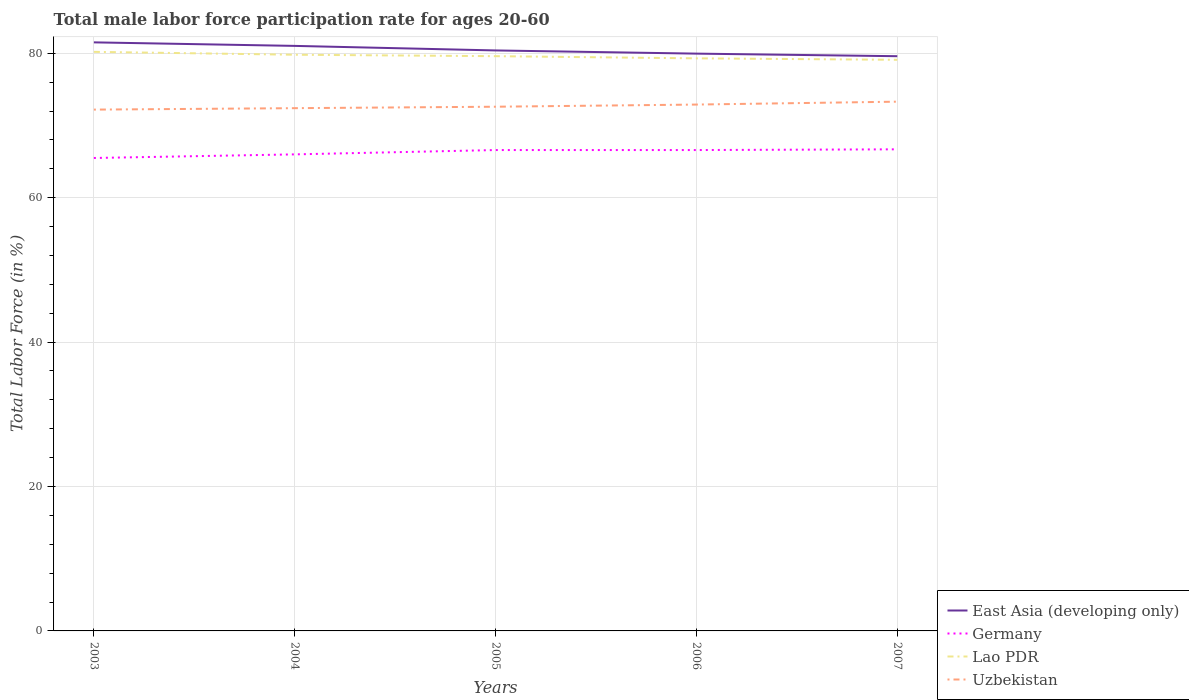Across all years, what is the maximum male labor force participation rate in East Asia (developing only)?
Give a very brief answer. 79.6. In which year was the male labor force participation rate in Lao PDR maximum?
Keep it short and to the point. 2007. What is the total male labor force participation rate in Germany in the graph?
Your answer should be compact. -0.6. What is the difference between the highest and the second highest male labor force participation rate in Lao PDR?
Offer a very short reply. 1.1. What is the difference between the highest and the lowest male labor force participation rate in Germany?
Your response must be concise. 3. What is the difference between two consecutive major ticks on the Y-axis?
Make the answer very short. 20. Are the values on the major ticks of Y-axis written in scientific E-notation?
Your answer should be compact. No. Does the graph contain grids?
Keep it short and to the point. Yes. How many legend labels are there?
Provide a succinct answer. 4. How are the legend labels stacked?
Offer a terse response. Vertical. What is the title of the graph?
Make the answer very short. Total male labor force participation rate for ages 20-60. Does "Isle of Man" appear as one of the legend labels in the graph?
Keep it short and to the point. No. What is the Total Labor Force (in %) of East Asia (developing only) in 2003?
Your answer should be very brief. 81.51. What is the Total Labor Force (in %) in Germany in 2003?
Your response must be concise. 65.5. What is the Total Labor Force (in %) of Lao PDR in 2003?
Provide a succinct answer. 80.2. What is the Total Labor Force (in %) in Uzbekistan in 2003?
Your response must be concise. 72.2. What is the Total Labor Force (in %) of East Asia (developing only) in 2004?
Your response must be concise. 81.02. What is the Total Labor Force (in %) of Germany in 2004?
Make the answer very short. 66. What is the Total Labor Force (in %) in Lao PDR in 2004?
Your response must be concise. 79.8. What is the Total Labor Force (in %) of Uzbekistan in 2004?
Offer a very short reply. 72.4. What is the Total Labor Force (in %) in East Asia (developing only) in 2005?
Ensure brevity in your answer.  80.39. What is the Total Labor Force (in %) in Germany in 2005?
Offer a terse response. 66.6. What is the Total Labor Force (in %) of Lao PDR in 2005?
Your response must be concise. 79.6. What is the Total Labor Force (in %) of Uzbekistan in 2005?
Make the answer very short. 72.6. What is the Total Labor Force (in %) in East Asia (developing only) in 2006?
Offer a terse response. 79.95. What is the Total Labor Force (in %) of Germany in 2006?
Your answer should be very brief. 66.6. What is the Total Labor Force (in %) of Lao PDR in 2006?
Provide a succinct answer. 79.3. What is the Total Labor Force (in %) in Uzbekistan in 2006?
Provide a short and direct response. 72.9. What is the Total Labor Force (in %) in East Asia (developing only) in 2007?
Your answer should be very brief. 79.6. What is the Total Labor Force (in %) of Germany in 2007?
Keep it short and to the point. 66.7. What is the Total Labor Force (in %) in Lao PDR in 2007?
Offer a terse response. 79.1. What is the Total Labor Force (in %) of Uzbekistan in 2007?
Offer a terse response. 73.3. Across all years, what is the maximum Total Labor Force (in %) of East Asia (developing only)?
Offer a terse response. 81.51. Across all years, what is the maximum Total Labor Force (in %) in Germany?
Offer a very short reply. 66.7. Across all years, what is the maximum Total Labor Force (in %) of Lao PDR?
Offer a terse response. 80.2. Across all years, what is the maximum Total Labor Force (in %) in Uzbekistan?
Your answer should be compact. 73.3. Across all years, what is the minimum Total Labor Force (in %) of East Asia (developing only)?
Offer a very short reply. 79.6. Across all years, what is the minimum Total Labor Force (in %) in Germany?
Your answer should be compact. 65.5. Across all years, what is the minimum Total Labor Force (in %) of Lao PDR?
Provide a succinct answer. 79.1. Across all years, what is the minimum Total Labor Force (in %) of Uzbekistan?
Keep it short and to the point. 72.2. What is the total Total Labor Force (in %) in East Asia (developing only) in the graph?
Ensure brevity in your answer.  402.48. What is the total Total Labor Force (in %) in Germany in the graph?
Give a very brief answer. 331.4. What is the total Total Labor Force (in %) of Lao PDR in the graph?
Provide a succinct answer. 398. What is the total Total Labor Force (in %) of Uzbekistan in the graph?
Offer a terse response. 363.4. What is the difference between the Total Labor Force (in %) of East Asia (developing only) in 2003 and that in 2004?
Your answer should be compact. 0.49. What is the difference between the Total Labor Force (in %) of Germany in 2003 and that in 2004?
Make the answer very short. -0.5. What is the difference between the Total Labor Force (in %) of Uzbekistan in 2003 and that in 2004?
Provide a short and direct response. -0.2. What is the difference between the Total Labor Force (in %) of East Asia (developing only) in 2003 and that in 2005?
Your response must be concise. 1.12. What is the difference between the Total Labor Force (in %) of Lao PDR in 2003 and that in 2005?
Give a very brief answer. 0.6. What is the difference between the Total Labor Force (in %) of Uzbekistan in 2003 and that in 2005?
Make the answer very short. -0.4. What is the difference between the Total Labor Force (in %) of East Asia (developing only) in 2003 and that in 2006?
Ensure brevity in your answer.  1.56. What is the difference between the Total Labor Force (in %) in Lao PDR in 2003 and that in 2006?
Your answer should be compact. 0.9. What is the difference between the Total Labor Force (in %) of East Asia (developing only) in 2003 and that in 2007?
Your answer should be very brief. 1.92. What is the difference between the Total Labor Force (in %) of Germany in 2003 and that in 2007?
Your response must be concise. -1.2. What is the difference between the Total Labor Force (in %) in East Asia (developing only) in 2004 and that in 2005?
Ensure brevity in your answer.  0.63. What is the difference between the Total Labor Force (in %) in East Asia (developing only) in 2004 and that in 2006?
Your response must be concise. 1.07. What is the difference between the Total Labor Force (in %) in East Asia (developing only) in 2004 and that in 2007?
Offer a very short reply. 1.43. What is the difference between the Total Labor Force (in %) of Uzbekistan in 2004 and that in 2007?
Make the answer very short. -0.9. What is the difference between the Total Labor Force (in %) in East Asia (developing only) in 2005 and that in 2006?
Your response must be concise. 0.44. What is the difference between the Total Labor Force (in %) in Germany in 2005 and that in 2006?
Ensure brevity in your answer.  0. What is the difference between the Total Labor Force (in %) in Lao PDR in 2005 and that in 2006?
Offer a very short reply. 0.3. What is the difference between the Total Labor Force (in %) in Uzbekistan in 2005 and that in 2006?
Provide a succinct answer. -0.3. What is the difference between the Total Labor Force (in %) of East Asia (developing only) in 2005 and that in 2007?
Your answer should be very brief. 0.8. What is the difference between the Total Labor Force (in %) in Uzbekistan in 2005 and that in 2007?
Make the answer very short. -0.7. What is the difference between the Total Labor Force (in %) of East Asia (developing only) in 2006 and that in 2007?
Keep it short and to the point. 0.36. What is the difference between the Total Labor Force (in %) of East Asia (developing only) in 2003 and the Total Labor Force (in %) of Germany in 2004?
Make the answer very short. 15.51. What is the difference between the Total Labor Force (in %) of East Asia (developing only) in 2003 and the Total Labor Force (in %) of Lao PDR in 2004?
Offer a very short reply. 1.71. What is the difference between the Total Labor Force (in %) of East Asia (developing only) in 2003 and the Total Labor Force (in %) of Uzbekistan in 2004?
Keep it short and to the point. 9.11. What is the difference between the Total Labor Force (in %) in Germany in 2003 and the Total Labor Force (in %) in Lao PDR in 2004?
Provide a short and direct response. -14.3. What is the difference between the Total Labor Force (in %) of Germany in 2003 and the Total Labor Force (in %) of Uzbekistan in 2004?
Your answer should be compact. -6.9. What is the difference between the Total Labor Force (in %) of East Asia (developing only) in 2003 and the Total Labor Force (in %) of Germany in 2005?
Keep it short and to the point. 14.91. What is the difference between the Total Labor Force (in %) in East Asia (developing only) in 2003 and the Total Labor Force (in %) in Lao PDR in 2005?
Your answer should be very brief. 1.91. What is the difference between the Total Labor Force (in %) in East Asia (developing only) in 2003 and the Total Labor Force (in %) in Uzbekistan in 2005?
Keep it short and to the point. 8.91. What is the difference between the Total Labor Force (in %) in Germany in 2003 and the Total Labor Force (in %) in Lao PDR in 2005?
Your answer should be compact. -14.1. What is the difference between the Total Labor Force (in %) of Germany in 2003 and the Total Labor Force (in %) of Uzbekistan in 2005?
Provide a succinct answer. -7.1. What is the difference between the Total Labor Force (in %) of Lao PDR in 2003 and the Total Labor Force (in %) of Uzbekistan in 2005?
Keep it short and to the point. 7.6. What is the difference between the Total Labor Force (in %) of East Asia (developing only) in 2003 and the Total Labor Force (in %) of Germany in 2006?
Give a very brief answer. 14.91. What is the difference between the Total Labor Force (in %) of East Asia (developing only) in 2003 and the Total Labor Force (in %) of Lao PDR in 2006?
Your response must be concise. 2.21. What is the difference between the Total Labor Force (in %) in East Asia (developing only) in 2003 and the Total Labor Force (in %) in Uzbekistan in 2006?
Give a very brief answer. 8.61. What is the difference between the Total Labor Force (in %) of Germany in 2003 and the Total Labor Force (in %) of Lao PDR in 2006?
Provide a succinct answer. -13.8. What is the difference between the Total Labor Force (in %) of Germany in 2003 and the Total Labor Force (in %) of Uzbekistan in 2006?
Provide a succinct answer. -7.4. What is the difference between the Total Labor Force (in %) in Lao PDR in 2003 and the Total Labor Force (in %) in Uzbekistan in 2006?
Keep it short and to the point. 7.3. What is the difference between the Total Labor Force (in %) of East Asia (developing only) in 2003 and the Total Labor Force (in %) of Germany in 2007?
Offer a very short reply. 14.81. What is the difference between the Total Labor Force (in %) in East Asia (developing only) in 2003 and the Total Labor Force (in %) in Lao PDR in 2007?
Ensure brevity in your answer.  2.41. What is the difference between the Total Labor Force (in %) in East Asia (developing only) in 2003 and the Total Labor Force (in %) in Uzbekistan in 2007?
Make the answer very short. 8.21. What is the difference between the Total Labor Force (in %) of Germany in 2003 and the Total Labor Force (in %) of Lao PDR in 2007?
Your answer should be very brief. -13.6. What is the difference between the Total Labor Force (in %) of Germany in 2003 and the Total Labor Force (in %) of Uzbekistan in 2007?
Provide a succinct answer. -7.8. What is the difference between the Total Labor Force (in %) of Lao PDR in 2003 and the Total Labor Force (in %) of Uzbekistan in 2007?
Offer a terse response. 6.9. What is the difference between the Total Labor Force (in %) in East Asia (developing only) in 2004 and the Total Labor Force (in %) in Germany in 2005?
Ensure brevity in your answer.  14.42. What is the difference between the Total Labor Force (in %) of East Asia (developing only) in 2004 and the Total Labor Force (in %) of Lao PDR in 2005?
Offer a very short reply. 1.42. What is the difference between the Total Labor Force (in %) in East Asia (developing only) in 2004 and the Total Labor Force (in %) in Uzbekistan in 2005?
Make the answer very short. 8.42. What is the difference between the Total Labor Force (in %) of East Asia (developing only) in 2004 and the Total Labor Force (in %) of Germany in 2006?
Give a very brief answer. 14.42. What is the difference between the Total Labor Force (in %) in East Asia (developing only) in 2004 and the Total Labor Force (in %) in Lao PDR in 2006?
Your answer should be compact. 1.72. What is the difference between the Total Labor Force (in %) in East Asia (developing only) in 2004 and the Total Labor Force (in %) in Uzbekistan in 2006?
Provide a short and direct response. 8.12. What is the difference between the Total Labor Force (in %) in Lao PDR in 2004 and the Total Labor Force (in %) in Uzbekistan in 2006?
Provide a short and direct response. 6.9. What is the difference between the Total Labor Force (in %) of East Asia (developing only) in 2004 and the Total Labor Force (in %) of Germany in 2007?
Your answer should be very brief. 14.32. What is the difference between the Total Labor Force (in %) in East Asia (developing only) in 2004 and the Total Labor Force (in %) in Lao PDR in 2007?
Give a very brief answer. 1.92. What is the difference between the Total Labor Force (in %) in East Asia (developing only) in 2004 and the Total Labor Force (in %) in Uzbekistan in 2007?
Your answer should be very brief. 7.72. What is the difference between the Total Labor Force (in %) in East Asia (developing only) in 2005 and the Total Labor Force (in %) in Germany in 2006?
Give a very brief answer. 13.79. What is the difference between the Total Labor Force (in %) in East Asia (developing only) in 2005 and the Total Labor Force (in %) in Lao PDR in 2006?
Your response must be concise. 1.09. What is the difference between the Total Labor Force (in %) in East Asia (developing only) in 2005 and the Total Labor Force (in %) in Uzbekistan in 2006?
Ensure brevity in your answer.  7.49. What is the difference between the Total Labor Force (in %) in Germany in 2005 and the Total Labor Force (in %) in Uzbekistan in 2006?
Provide a short and direct response. -6.3. What is the difference between the Total Labor Force (in %) of East Asia (developing only) in 2005 and the Total Labor Force (in %) of Germany in 2007?
Offer a very short reply. 13.69. What is the difference between the Total Labor Force (in %) of East Asia (developing only) in 2005 and the Total Labor Force (in %) of Lao PDR in 2007?
Offer a terse response. 1.29. What is the difference between the Total Labor Force (in %) of East Asia (developing only) in 2005 and the Total Labor Force (in %) of Uzbekistan in 2007?
Your answer should be very brief. 7.09. What is the difference between the Total Labor Force (in %) in Germany in 2005 and the Total Labor Force (in %) in Lao PDR in 2007?
Give a very brief answer. -12.5. What is the difference between the Total Labor Force (in %) of East Asia (developing only) in 2006 and the Total Labor Force (in %) of Germany in 2007?
Your response must be concise. 13.25. What is the difference between the Total Labor Force (in %) of East Asia (developing only) in 2006 and the Total Labor Force (in %) of Lao PDR in 2007?
Provide a succinct answer. 0.85. What is the difference between the Total Labor Force (in %) in East Asia (developing only) in 2006 and the Total Labor Force (in %) in Uzbekistan in 2007?
Your response must be concise. 6.65. What is the difference between the Total Labor Force (in %) of Germany in 2006 and the Total Labor Force (in %) of Uzbekistan in 2007?
Give a very brief answer. -6.7. What is the difference between the Total Labor Force (in %) of Lao PDR in 2006 and the Total Labor Force (in %) of Uzbekistan in 2007?
Your answer should be compact. 6. What is the average Total Labor Force (in %) in East Asia (developing only) per year?
Make the answer very short. 80.5. What is the average Total Labor Force (in %) of Germany per year?
Provide a short and direct response. 66.28. What is the average Total Labor Force (in %) of Lao PDR per year?
Your response must be concise. 79.6. What is the average Total Labor Force (in %) of Uzbekistan per year?
Provide a short and direct response. 72.68. In the year 2003, what is the difference between the Total Labor Force (in %) of East Asia (developing only) and Total Labor Force (in %) of Germany?
Your response must be concise. 16.01. In the year 2003, what is the difference between the Total Labor Force (in %) in East Asia (developing only) and Total Labor Force (in %) in Lao PDR?
Make the answer very short. 1.31. In the year 2003, what is the difference between the Total Labor Force (in %) in East Asia (developing only) and Total Labor Force (in %) in Uzbekistan?
Keep it short and to the point. 9.31. In the year 2003, what is the difference between the Total Labor Force (in %) of Germany and Total Labor Force (in %) of Lao PDR?
Your response must be concise. -14.7. In the year 2003, what is the difference between the Total Labor Force (in %) of Lao PDR and Total Labor Force (in %) of Uzbekistan?
Ensure brevity in your answer.  8. In the year 2004, what is the difference between the Total Labor Force (in %) in East Asia (developing only) and Total Labor Force (in %) in Germany?
Ensure brevity in your answer.  15.02. In the year 2004, what is the difference between the Total Labor Force (in %) in East Asia (developing only) and Total Labor Force (in %) in Lao PDR?
Provide a succinct answer. 1.22. In the year 2004, what is the difference between the Total Labor Force (in %) in East Asia (developing only) and Total Labor Force (in %) in Uzbekistan?
Ensure brevity in your answer.  8.62. In the year 2004, what is the difference between the Total Labor Force (in %) of Lao PDR and Total Labor Force (in %) of Uzbekistan?
Keep it short and to the point. 7.4. In the year 2005, what is the difference between the Total Labor Force (in %) in East Asia (developing only) and Total Labor Force (in %) in Germany?
Make the answer very short. 13.79. In the year 2005, what is the difference between the Total Labor Force (in %) of East Asia (developing only) and Total Labor Force (in %) of Lao PDR?
Keep it short and to the point. 0.79. In the year 2005, what is the difference between the Total Labor Force (in %) in East Asia (developing only) and Total Labor Force (in %) in Uzbekistan?
Offer a very short reply. 7.79. In the year 2005, what is the difference between the Total Labor Force (in %) of Germany and Total Labor Force (in %) of Lao PDR?
Offer a terse response. -13. In the year 2005, what is the difference between the Total Labor Force (in %) of Germany and Total Labor Force (in %) of Uzbekistan?
Provide a short and direct response. -6. In the year 2005, what is the difference between the Total Labor Force (in %) of Lao PDR and Total Labor Force (in %) of Uzbekistan?
Offer a terse response. 7. In the year 2006, what is the difference between the Total Labor Force (in %) in East Asia (developing only) and Total Labor Force (in %) in Germany?
Your answer should be very brief. 13.35. In the year 2006, what is the difference between the Total Labor Force (in %) in East Asia (developing only) and Total Labor Force (in %) in Lao PDR?
Your response must be concise. 0.65. In the year 2006, what is the difference between the Total Labor Force (in %) of East Asia (developing only) and Total Labor Force (in %) of Uzbekistan?
Make the answer very short. 7.05. In the year 2006, what is the difference between the Total Labor Force (in %) in Germany and Total Labor Force (in %) in Lao PDR?
Give a very brief answer. -12.7. In the year 2006, what is the difference between the Total Labor Force (in %) of Germany and Total Labor Force (in %) of Uzbekistan?
Keep it short and to the point. -6.3. In the year 2006, what is the difference between the Total Labor Force (in %) in Lao PDR and Total Labor Force (in %) in Uzbekistan?
Ensure brevity in your answer.  6.4. In the year 2007, what is the difference between the Total Labor Force (in %) in East Asia (developing only) and Total Labor Force (in %) in Germany?
Offer a terse response. 12.9. In the year 2007, what is the difference between the Total Labor Force (in %) of East Asia (developing only) and Total Labor Force (in %) of Lao PDR?
Your answer should be very brief. 0.5. In the year 2007, what is the difference between the Total Labor Force (in %) in East Asia (developing only) and Total Labor Force (in %) in Uzbekistan?
Give a very brief answer. 6.3. In the year 2007, what is the difference between the Total Labor Force (in %) of Germany and Total Labor Force (in %) of Lao PDR?
Your response must be concise. -12.4. What is the ratio of the Total Labor Force (in %) in Germany in 2003 to that in 2004?
Offer a terse response. 0.99. What is the ratio of the Total Labor Force (in %) of East Asia (developing only) in 2003 to that in 2005?
Provide a short and direct response. 1.01. What is the ratio of the Total Labor Force (in %) of Germany in 2003 to that in 2005?
Offer a very short reply. 0.98. What is the ratio of the Total Labor Force (in %) in Lao PDR in 2003 to that in 2005?
Make the answer very short. 1.01. What is the ratio of the Total Labor Force (in %) in Uzbekistan in 2003 to that in 2005?
Ensure brevity in your answer.  0.99. What is the ratio of the Total Labor Force (in %) of East Asia (developing only) in 2003 to that in 2006?
Offer a very short reply. 1.02. What is the ratio of the Total Labor Force (in %) in Germany in 2003 to that in 2006?
Provide a short and direct response. 0.98. What is the ratio of the Total Labor Force (in %) of Lao PDR in 2003 to that in 2006?
Offer a very short reply. 1.01. What is the ratio of the Total Labor Force (in %) of Uzbekistan in 2003 to that in 2006?
Provide a short and direct response. 0.99. What is the ratio of the Total Labor Force (in %) of East Asia (developing only) in 2003 to that in 2007?
Provide a short and direct response. 1.02. What is the ratio of the Total Labor Force (in %) of Germany in 2003 to that in 2007?
Your answer should be very brief. 0.98. What is the ratio of the Total Labor Force (in %) of Lao PDR in 2003 to that in 2007?
Your response must be concise. 1.01. What is the ratio of the Total Labor Force (in %) of East Asia (developing only) in 2004 to that in 2006?
Your answer should be very brief. 1.01. What is the ratio of the Total Labor Force (in %) of East Asia (developing only) in 2004 to that in 2007?
Your response must be concise. 1.02. What is the ratio of the Total Labor Force (in %) in Lao PDR in 2004 to that in 2007?
Provide a succinct answer. 1.01. What is the ratio of the Total Labor Force (in %) in Uzbekistan in 2005 to that in 2006?
Ensure brevity in your answer.  1. What is the ratio of the Total Labor Force (in %) of East Asia (developing only) in 2005 to that in 2007?
Ensure brevity in your answer.  1.01. What is the ratio of the Total Labor Force (in %) in Lao PDR in 2005 to that in 2007?
Your answer should be very brief. 1.01. What is the ratio of the Total Labor Force (in %) in Germany in 2006 to that in 2007?
Keep it short and to the point. 1. What is the ratio of the Total Labor Force (in %) in Lao PDR in 2006 to that in 2007?
Provide a succinct answer. 1. What is the difference between the highest and the second highest Total Labor Force (in %) in East Asia (developing only)?
Keep it short and to the point. 0.49. What is the difference between the highest and the lowest Total Labor Force (in %) of East Asia (developing only)?
Your answer should be very brief. 1.92. What is the difference between the highest and the lowest Total Labor Force (in %) of Germany?
Give a very brief answer. 1.2. What is the difference between the highest and the lowest Total Labor Force (in %) of Lao PDR?
Provide a succinct answer. 1.1. 